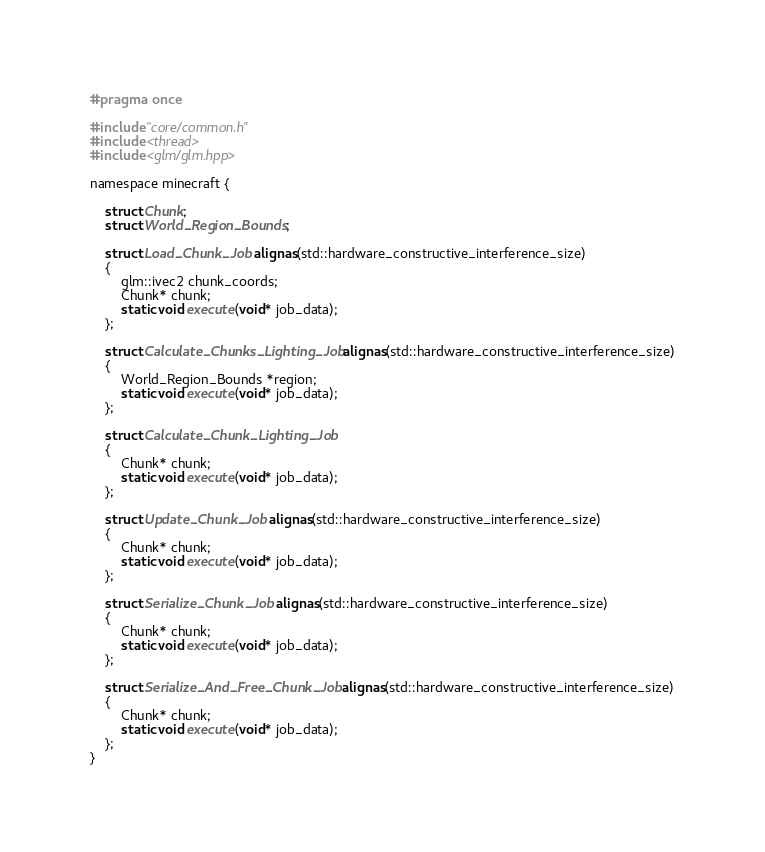<code> <loc_0><loc_0><loc_500><loc_500><_C_>#pragma once

#include "core/common.h"
#include <thread>
#include <glm/glm.hpp>

namespace minecraft {

    struct Chunk;
    struct World_Region_Bounds;

    struct Load_Chunk_Job alignas(std::hardware_constructive_interference_size)
    {
        glm::ivec2 chunk_coords;
        Chunk* chunk;
        static void execute(void* job_data);
    };

    struct Calculate_Chunks_Lighting_Job alignas(std::hardware_constructive_interference_size)
    {
        World_Region_Bounds *region;
        static void execute(void* job_data);
    };

    struct Calculate_Chunk_Lighting_Job
    {
        Chunk* chunk;
        static void execute(void* job_data);
    };

    struct Update_Chunk_Job alignas(std::hardware_constructive_interference_size)
    {
        Chunk* chunk;
        static void execute(void* job_data);
    };

    struct Serialize_Chunk_Job alignas(std::hardware_constructive_interference_size)
    {
        Chunk* chunk;
        static void execute(void* job_data);
    };

    struct Serialize_And_Free_Chunk_Job alignas(std::hardware_constructive_interference_size)
    {
        Chunk* chunk;
        static void execute(void* job_data);
    };
}</code> 